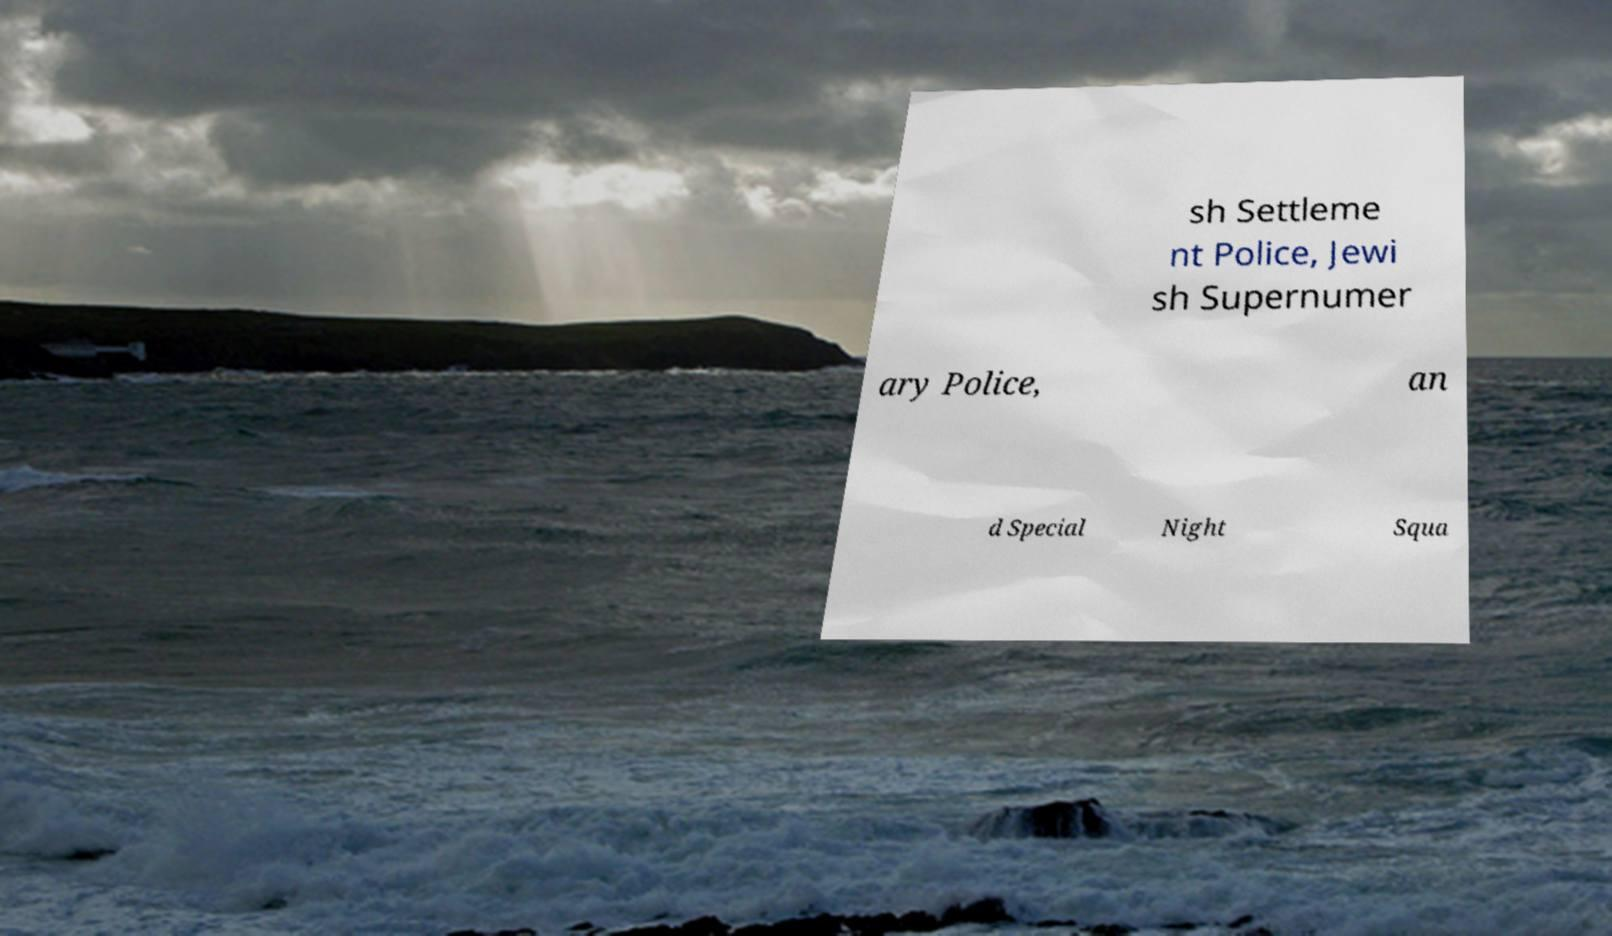I need the written content from this picture converted into text. Can you do that? sh Settleme nt Police, Jewi sh Supernumer ary Police, an d Special Night Squa 